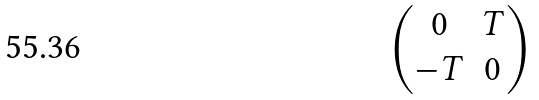<formula> <loc_0><loc_0><loc_500><loc_500>\begin{pmatrix} 0 & T \\ - T & 0 \end{pmatrix}</formula> 